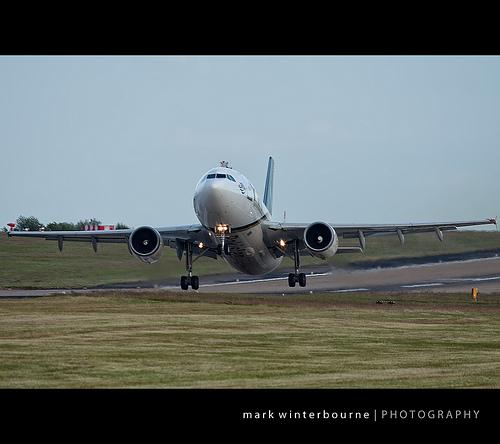Count the number of white clouds present in the blue sky. There are 19 white clouds in the blue sky. Describe the color and size of the traffic cone in the image. An orange traffic cone is on the ground, with a Width of 22 and Height of 22. Examine the object interactions in the image. The airplane is interacting with the environment by taking off from the runway, surrounded by white clouds, short green grass, trees in the distance, and a traffic cone on the ground. How many wheels are present on the ground and what are their colors? There are two small black wheels on the ground with a width of 31 and height of 31. What are the environmental characteristics in the image? There are white clouds in the blue sky, short green grass on the ground, and a line of trees in the distance. Explain the presence of lights on the plane. There is a small yellow light on the plane with a Width of 25 and Height of 25, and multiple lights on the underside with a Width of 103 and Height of 103. Can you see the red clouds at X:123, Y:141 with width 60 and height 60? The clouds in the image are described as "white clouds in blue sky," not as "red clouds." The color attribute is incorrect. Can you find a tree line in the distance at X:500, Y:500 with width 200 and height 140? The positions and size attributes are incorrect for the tree line. The correct position and size are X:10, Y:212 with width 140 and height 140. Is the purple airplane located at X:4, Y:138 with width 455 and height 455? The airplane is mentioned as "large airplane" and "plane" in the image, not as "purple airplane." The color attribute is incorrect. Are there blue lights on the underside of the plane at X:190, Y:214 with width 103 and height 103? The lights on the underside of the plane are mentioned as "multiple lights" without specifying any color. The color attribute is incorrect. Is there a pink traffic cone at X:465, Y:285 with width 22 and height 22? The traffic cone in the image is mentioned as "orange traffic cone," not as "pink traffic cone." The color attribute is incorrect. Is there a long green grass growing on the ground at X:84, Y:308 with width 306 and height 306? The grass in the image is described as "short green grass," not as "long green grass." The length attribute is incorrect. 